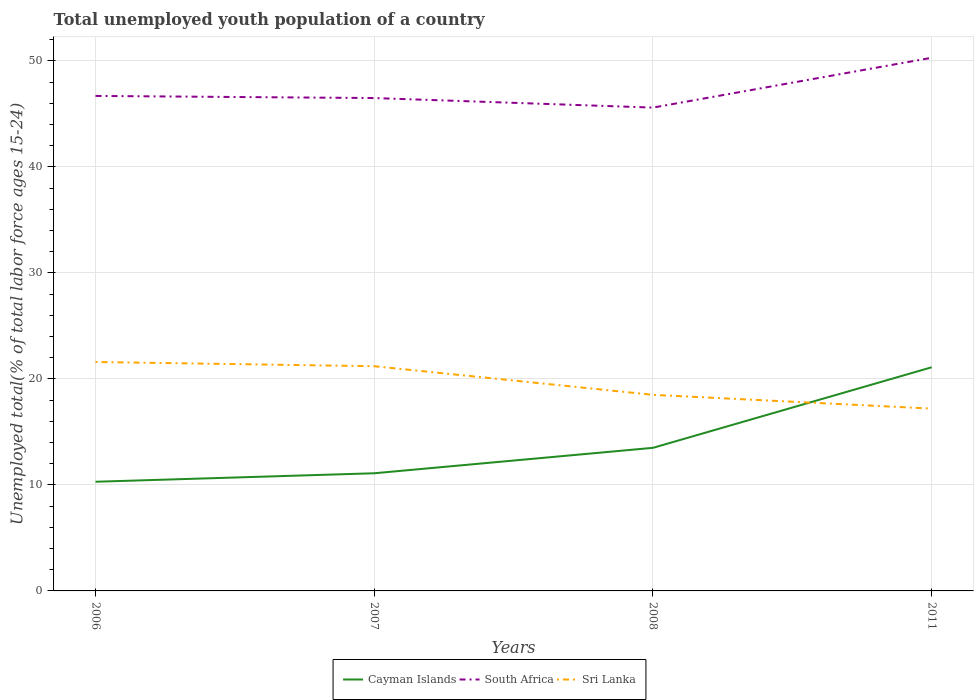Does the line corresponding to Cayman Islands intersect with the line corresponding to Sri Lanka?
Provide a succinct answer. Yes. Across all years, what is the maximum percentage of total unemployed youth population of a country in South Africa?
Your response must be concise. 45.6. What is the total percentage of total unemployed youth population of a country in Sri Lanka in the graph?
Offer a terse response. 2.7. What is the difference between the highest and the second highest percentage of total unemployed youth population of a country in Cayman Islands?
Your response must be concise. 10.8. How many lines are there?
Provide a succinct answer. 3. How many years are there in the graph?
Your answer should be very brief. 4. Are the values on the major ticks of Y-axis written in scientific E-notation?
Offer a terse response. No. Does the graph contain any zero values?
Make the answer very short. No. What is the title of the graph?
Offer a terse response. Total unemployed youth population of a country. What is the label or title of the X-axis?
Your answer should be very brief. Years. What is the label or title of the Y-axis?
Your answer should be compact. Unemployed total(% of total labor force ages 15-24). What is the Unemployed total(% of total labor force ages 15-24) of Cayman Islands in 2006?
Ensure brevity in your answer.  10.3. What is the Unemployed total(% of total labor force ages 15-24) in South Africa in 2006?
Your answer should be very brief. 46.7. What is the Unemployed total(% of total labor force ages 15-24) in Sri Lanka in 2006?
Provide a short and direct response. 21.6. What is the Unemployed total(% of total labor force ages 15-24) in Cayman Islands in 2007?
Offer a terse response. 11.1. What is the Unemployed total(% of total labor force ages 15-24) of South Africa in 2007?
Make the answer very short. 46.5. What is the Unemployed total(% of total labor force ages 15-24) in Sri Lanka in 2007?
Offer a terse response. 21.2. What is the Unemployed total(% of total labor force ages 15-24) of South Africa in 2008?
Your response must be concise. 45.6. What is the Unemployed total(% of total labor force ages 15-24) in Cayman Islands in 2011?
Your response must be concise. 21.1. What is the Unemployed total(% of total labor force ages 15-24) in South Africa in 2011?
Your answer should be very brief. 50.3. What is the Unemployed total(% of total labor force ages 15-24) of Sri Lanka in 2011?
Offer a terse response. 17.2. Across all years, what is the maximum Unemployed total(% of total labor force ages 15-24) of Cayman Islands?
Provide a succinct answer. 21.1. Across all years, what is the maximum Unemployed total(% of total labor force ages 15-24) in South Africa?
Make the answer very short. 50.3. Across all years, what is the maximum Unemployed total(% of total labor force ages 15-24) of Sri Lanka?
Keep it short and to the point. 21.6. Across all years, what is the minimum Unemployed total(% of total labor force ages 15-24) in Cayman Islands?
Offer a very short reply. 10.3. Across all years, what is the minimum Unemployed total(% of total labor force ages 15-24) in South Africa?
Offer a terse response. 45.6. Across all years, what is the minimum Unemployed total(% of total labor force ages 15-24) in Sri Lanka?
Your response must be concise. 17.2. What is the total Unemployed total(% of total labor force ages 15-24) of South Africa in the graph?
Make the answer very short. 189.1. What is the total Unemployed total(% of total labor force ages 15-24) in Sri Lanka in the graph?
Offer a terse response. 78.5. What is the difference between the Unemployed total(% of total labor force ages 15-24) in Cayman Islands in 2006 and that in 2007?
Provide a short and direct response. -0.8. What is the difference between the Unemployed total(% of total labor force ages 15-24) in South Africa in 2006 and that in 2008?
Provide a succinct answer. 1.1. What is the difference between the Unemployed total(% of total labor force ages 15-24) in Cayman Islands in 2006 and that in 2011?
Keep it short and to the point. -10.8. What is the difference between the Unemployed total(% of total labor force ages 15-24) of Sri Lanka in 2006 and that in 2011?
Offer a very short reply. 4.4. What is the difference between the Unemployed total(% of total labor force ages 15-24) in South Africa in 2007 and that in 2008?
Keep it short and to the point. 0.9. What is the difference between the Unemployed total(% of total labor force ages 15-24) in South Africa in 2007 and that in 2011?
Your answer should be compact. -3.8. What is the difference between the Unemployed total(% of total labor force ages 15-24) of Sri Lanka in 2007 and that in 2011?
Ensure brevity in your answer.  4. What is the difference between the Unemployed total(% of total labor force ages 15-24) of South Africa in 2008 and that in 2011?
Ensure brevity in your answer.  -4.7. What is the difference between the Unemployed total(% of total labor force ages 15-24) in Sri Lanka in 2008 and that in 2011?
Provide a succinct answer. 1.3. What is the difference between the Unemployed total(% of total labor force ages 15-24) of Cayman Islands in 2006 and the Unemployed total(% of total labor force ages 15-24) of South Africa in 2007?
Offer a terse response. -36.2. What is the difference between the Unemployed total(% of total labor force ages 15-24) of South Africa in 2006 and the Unemployed total(% of total labor force ages 15-24) of Sri Lanka in 2007?
Provide a succinct answer. 25.5. What is the difference between the Unemployed total(% of total labor force ages 15-24) of Cayman Islands in 2006 and the Unemployed total(% of total labor force ages 15-24) of South Africa in 2008?
Keep it short and to the point. -35.3. What is the difference between the Unemployed total(% of total labor force ages 15-24) of Cayman Islands in 2006 and the Unemployed total(% of total labor force ages 15-24) of Sri Lanka in 2008?
Ensure brevity in your answer.  -8.2. What is the difference between the Unemployed total(% of total labor force ages 15-24) in South Africa in 2006 and the Unemployed total(% of total labor force ages 15-24) in Sri Lanka in 2008?
Provide a short and direct response. 28.2. What is the difference between the Unemployed total(% of total labor force ages 15-24) in Cayman Islands in 2006 and the Unemployed total(% of total labor force ages 15-24) in South Africa in 2011?
Your answer should be compact. -40. What is the difference between the Unemployed total(% of total labor force ages 15-24) in Cayman Islands in 2006 and the Unemployed total(% of total labor force ages 15-24) in Sri Lanka in 2011?
Ensure brevity in your answer.  -6.9. What is the difference between the Unemployed total(% of total labor force ages 15-24) of South Africa in 2006 and the Unemployed total(% of total labor force ages 15-24) of Sri Lanka in 2011?
Provide a short and direct response. 29.5. What is the difference between the Unemployed total(% of total labor force ages 15-24) of Cayman Islands in 2007 and the Unemployed total(% of total labor force ages 15-24) of South Africa in 2008?
Your answer should be very brief. -34.5. What is the difference between the Unemployed total(% of total labor force ages 15-24) of Cayman Islands in 2007 and the Unemployed total(% of total labor force ages 15-24) of Sri Lanka in 2008?
Your response must be concise. -7.4. What is the difference between the Unemployed total(% of total labor force ages 15-24) in Cayman Islands in 2007 and the Unemployed total(% of total labor force ages 15-24) in South Africa in 2011?
Your answer should be very brief. -39.2. What is the difference between the Unemployed total(% of total labor force ages 15-24) in South Africa in 2007 and the Unemployed total(% of total labor force ages 15-24) in Sri Lanka in 2011?
Offer a very short reply. 29.3. What is the difference between the Unemployed total(% of total labor force ages 15-24) of Cayman Islands in 2008 and the Unemployed total(% of total labor force ages 15-24) of South Africa in 2011?
Make the answer very short. -36.8. What is the difference between the Unemployed total(% of total labor force ages 15-24) in Cayman Islands in 2008 and the Unemployed total(% of total labor force ages 15-24) in Sri Lanka in 2011?
Keep it short and to the point. -3.7. What is the difference between the Unemployed total(% of total labor force ages 15-24) of South Africa in 2008 and the Unemployed total(% of total labor force ages 15-24) of Sri Lanka in 2011?
Provide a succinct answer. 28.4. What is the average Unemployed total(% of total labor force ages 15-24) of Cayman Islands per year?
Your answer should be compact. 14. What is the average Unemployed total(% of total labor force ages 15-24) of South Africa per year?
Offer a very short reply. 47.27. What is the average Unemployed total(% of total labor force ages 15-24) in Sri Lanka per year?
Offer a very short reply. 19.62. In the year 2006, what is the difference between the Unemployed total(% of total labor force ages 15-24) of Cayman Islands and Unemployed total(% of total labor force ages 15-24) of South Africa?
Give a very brief answer. -36.4. In the year 2006, what is the difference between the Unemployed total(% of total labor force ages 15-24) of South Africa and Unemployed total(% of total labor force ages 15-24) of Sri Lanka?
Give a very brief answer. 25.1. In the year 2007, what is the difference between the Unemployed total(% of total labor force ages 15-24) in Cayman Islands and Unemployed total(% of total labor force ages 15-24) in South Africa?
Offer a very short reply. -35.4. In the year 2007, what is the difference between the Unemployed total(% of total labor force ages 15-24) of South Africa and Unemployed total(% of total labor force ages 15-24) of Sri Lanka?
Your response must be concise. 25.3. In the year 2008, what is the difference between the Unemployed total(% of total labor force ages 15-24) of Cayman Islands and Unemployed total(% of total labor force ages 15-24) of South Africa?
Your response must be concise. -32.1. In the year 2008, what is the difference between the Unemployed total(% of total labor force ages 15-24) of South Africa and Unemployed total(% of total labor force ages 15-24) of Sri Lanka?
Provide a succinct answer. 27.1. In the year 2011, what is the difference between the Unemployed total(% of total labor force ages 15-24) in Cayman Islands and Unemployed total(% of total labor force ages 15-24) in South Africa?
Provide a succinct answer. -29.2. In the year 2011, what is the difference between the Unemployed total(% of total labor force ages 15-24) in South Africa and Unemployed total(% of total labor force ages 15-24) in Sri Lanka?
Provide a succinct answer. 33.1. What is the ratio of the Unemployed total(% of total labor force ages 15-24) in Cayman Islands in 2006 to that in 2007?
Keep it short and to the point. 0.93. What is the ratio of the Unemployed total(% of total labor force ages 15-24) in South Africa in 2006 to that in 2007?
Offer a terse response. 1. What is the ratio of the Unemployed total(% of total labor force ages 15-24) of Sri Lanka in 2006 to that in 2007?
Ensure brevity in your answer.  1.02. What is the ratio of the Unemployed total(% of total labor force ages 15-24) in Cayman Islands in 2006 to that in 2008?
Your response must be concise. 0.76. What is the ratio of the Unemployed total(% of total labor force ages 15-24) in South Africa in 2006 to that in 2008?
Give a very brief answer. 1.02. What is the ratio of the Unemployed total(% of total labor force ages 15-24) in Sri Lanka in 2006 to that in 2008?
Your response must be concise. 1.17. What is the ratio of the Unemployed total(% of total labor force ages 15-24) in Cayman Islands in 2006 to that in 2011?
Give a very brief answer. 0.49. What is the ratio of the Unemployed total(% of total labor force ages 15-24) of South Africa in 2006 to that in 2011?
Provide a short and direct response. 0.93. What is the ratio of the Unemployed total(% of total labor force ages 15-24) of Sri Lanka in 2006 to that in 2011?
Make the answer very short. 1.26. What is the ratio of the Unemployed total(% of total labor force ages 15-24) of Cayman Islands in 2007 to that in 2008?
Your answer should be very brief. 0.82. What is the ratio of the Unemployed total(% of total labor force ages 15-24) in South Africa in 2007 to that in 2008?
Provide a succinct answer. 1.02. What is the ratio of the Unemployed total(% of total labor force ages 15-24) in Sri Lanka in 2007 to that in 2008?
Offer a terse response. 1.15. What is the ratio of the Unemployed total(% of total labor force ages 15-24) in Cayman Islands in 2007 to that in 2011?
Make the answer very short. 0.53. What is the ratio of the Unemployed total(% of total labor force ages 15-24) in South Africa in 2007 to that in 2011?
Offer a very short reply. 0.92. What is the ratio of the Unemployed total(% of total labor force ages 15-24) in Sri Lanka in 2007 to that in 2011?
Provide a succinct answer. 1.23. What is the ratio of the Unemployed total(% of total labor force ages 15-24) in Cayman Islands in 2008 to that in 2011?
Your answer should be very brief. 0.64. What is the ratio of the Unemployed total(% of total labor force ages 15-24) in South Africa in 2008 to that in 2011?
Your answer should be compact. 0.91. What is the ratio of the Unemployed total(% of total labor force ages 15-24) of Sri Lanka in 2008 to that in 2011?
Offer a very short reply. 1.08. What is the difference between the highest and the second highest Unemployed total(% of total labor force ages 15-24) of Cayman Islands?
Your answer should be compact. 7.6. What is the difference between the highest and the second highest Unemployed total(% of total labor force ages 15-24) in South Africa?
Provide a short and direct response. 3.6. What is the difference between the highest and the second highest Unemployed total(% of total labor force ages 15-24) of Sri Lanka?
Offer a terse response. 0.4. What is the difference between the highest and the lowest Unemployed total(% of total labor force ages 15-24) in Cayman Islands?
Your response must be concise. 10.8. What is the difference between the highest and the lowest Unemployed total(% of total labor force ages 15-24) in South Africa?
Your answer should be very brief. 4.7. 